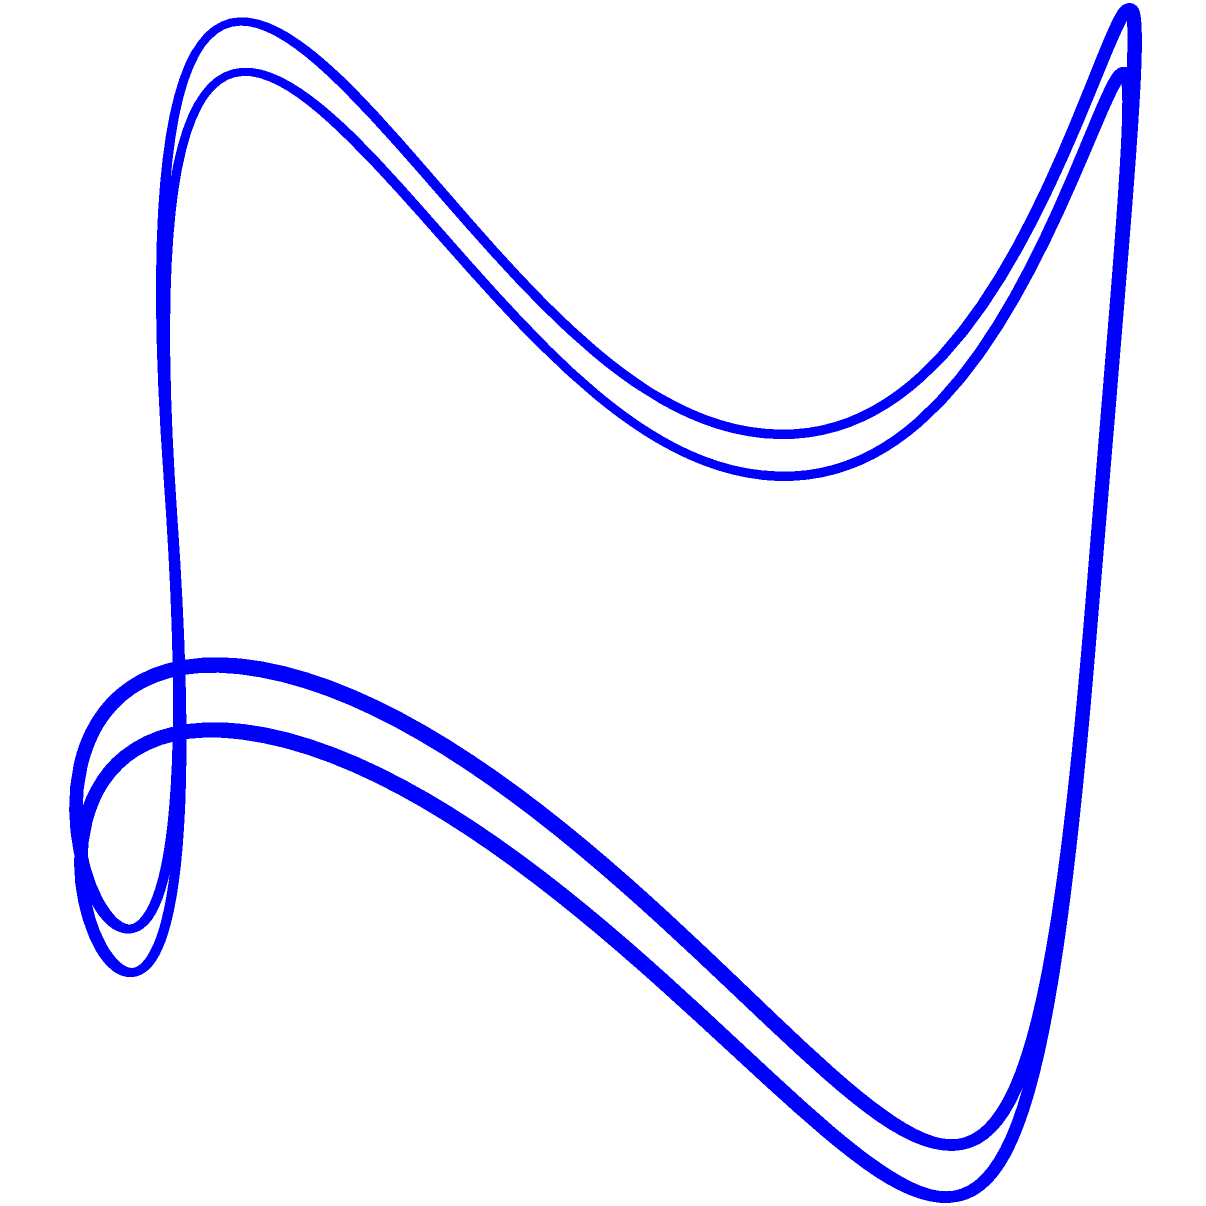Consider the figure-eight knot shown in the diagram. Determine the fundamental group $\pi_1(S^3 \setminus K)$ of the knot complement, where $K$ represents the figure-eight knot and $S^3$ is the 3-sphere. How many generators does this group have, and what is its presentation? To find the fundamental group of the figure-eight knot complement, we follow these steps:

1) The figure-eight knot is a prime knot, meaning it cannot be decomposed into simpler knots.

2) For any knot $K$ in $S^3$, the fundamental group $\pi_1(S^3 \setminus K)$ is called the knot group.

3) The Wirtinger presentation is a method to find a presentation for the knot group. In this presentation, each arc of the knot diagram corresponds to a generator.

4) For the figure-eight knot, we have two generators, typically denoted as $a$ and $b$.

5) The relations in the Wirtinger presentation come from the crossings in the knot diagram. For the figure-eight knot, we have two relations:

   $aba^{-1}b^{-1}ab = bab^{-1}a^{-1}$
   $bab^{-1}a^{-1}ba = aba^{-1}b^{-1}$

6) Therefore, the presentation of the fundamental group is:

   $\pi_1(S^3 \setminus K) = \langle a, b \mid aba^{-1}b^{-1}ab = bab^{-1}a^{-1}, bab^{-1}a^{-1}ba = aba^{-1}b^{-1} \rangle$

This group has two generators and two relations.
Answer: $\langle a, b \mid aba^{-1}b^{-1}ab = bab^{-1}a^{-1}, bab^{-1}a^{-1}ba = aba^{-1}b^{-1} \rangle$, with 2 generators 